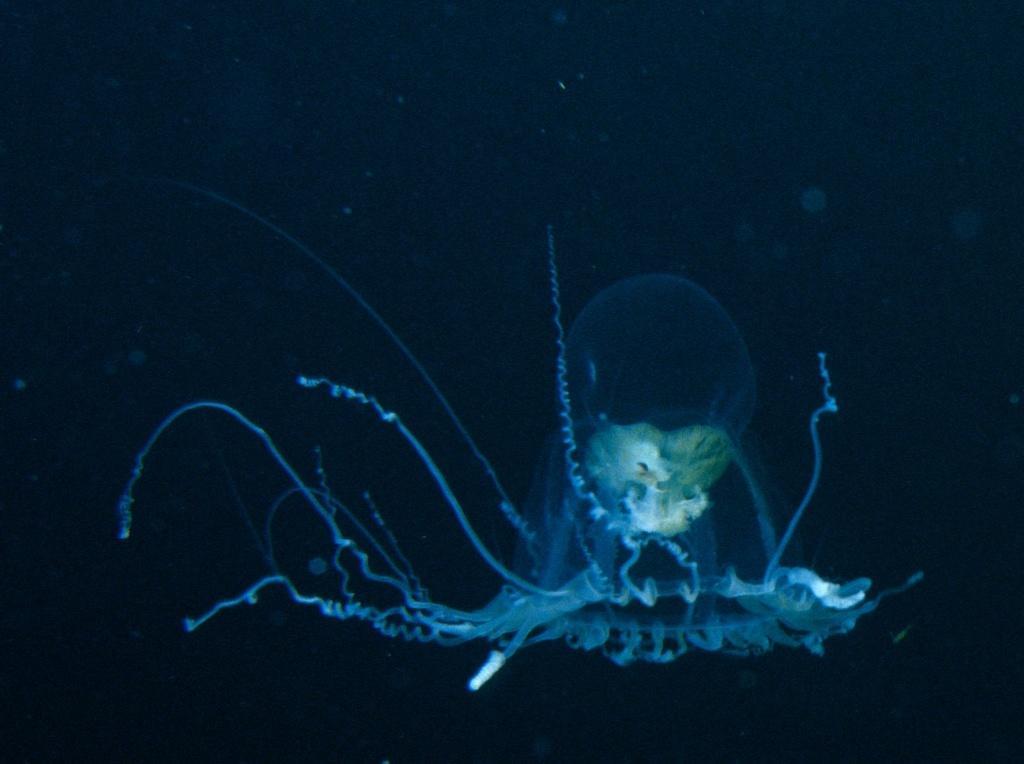In one or two sentences, can you explain what this image depicts? In the center of the image we can see one jellyfish. And we can see the dark background. 